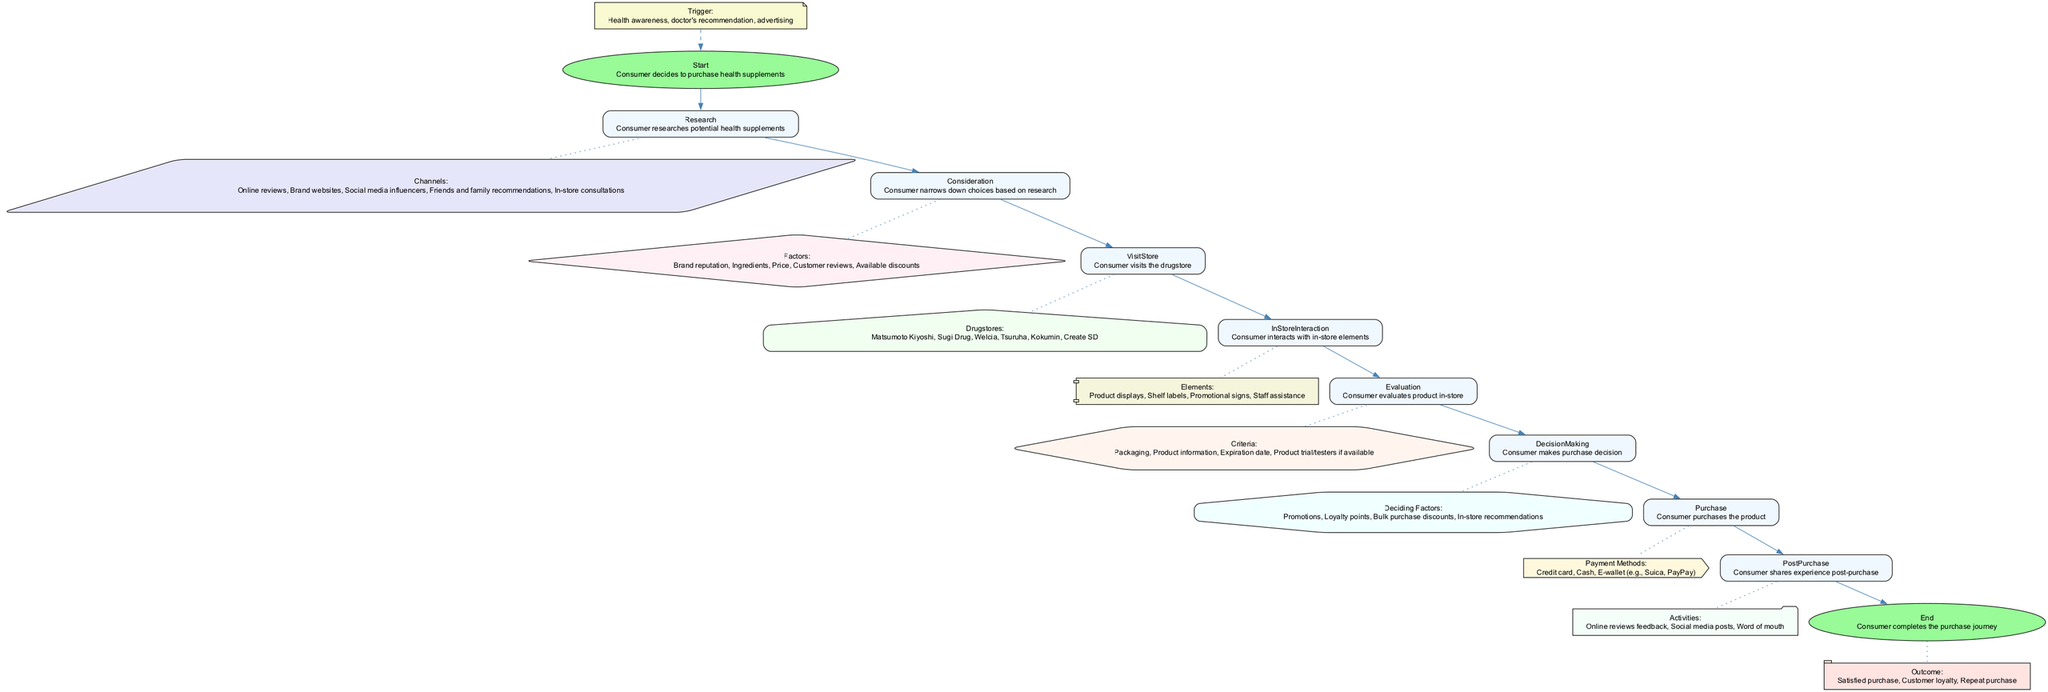What is the initial trigger for the consumer's purchase journey? The first step in the flowchart states that the consumer's journey begins with a decision to purchase health supplements triggered by health awareness, doctor's recommendation, or advertising. Therefore, the initial trigger can be identified directly from this description.
Answer: Health awareness, doctor's recommendation, advertising How many drugstore chains are listed in the VisitStore step? The VisitStore step includes a list of drugstore chains that the consumer can visit. By counting each drugstore mentioned, we find that there are six drugstores specified in this step.
Answer: 6 What are the evaluation criteria listed in the Evaluation step? The Evaluation step outlines several criteria that a consumer considers while evaluating products in-store. It includes packaging, product information, expiration date, and product trial/testers if available. This information can be found in the description of the Evaluate node.
Answer: Packaging, product information, expiration date, product trial/testers if available What is the last activity mentioned in the PostPurchase stage? In the PostPurchase stage, the consumer is involved in activities such as online reviews feedback, social media posts, and word of mouth. The last activity mentioned at the end of this section is word of mouth, which can be directly referenced.
Answer: Word of mouth Which two main steps are connected directly to the DecisionMaking step? The DecisionMaking step is situated between two preceding main steps: Evaluation and Purchase. The flowchart shows direct connections leading into and out of the DecisionMaking step, indicating its placement in the overall journey direction.
Answer: Evaluation, Purchase What factors influence the consumer during the Consideration step? The Consideration step lists specific factors that influence the consumer's choices while narrowing down options. By analyzing this step's contents, we find the factors stated are brand reputation, ingredients, price, customer reviews, and available discounts.
Answer: Brand reputation, ingredients, price, customer reviews, available discounts What payment methods does the consumer have in the Purchase step? The Purchase step details various payment methods available to the consumer. By examining this section of the flowchart, we can see that credit card, cash, and e-wallet (e.g., Suica, PayPay) are the stated payment options.
Answer: Credit card, cash, e-wallet (e.g., Suica, PayPay) What is the outcome after the consumer completes the journey? The final step of the journey, End, outlines several possible outcomes from the consumer's experience. This includes a satisfied purchase, customer loyalty, and a repeat purchase, which summarizes the potential impacts following the purchase journey.
Answer: Satisfied purchase, customer loyalty, repeat purchase 